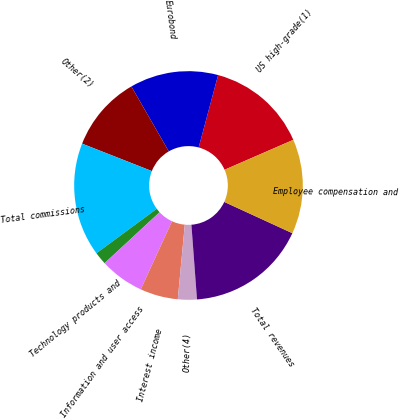Convert chart. <chart><loc_0><loc_0><loc_500><loc_500><pie_chart><fcel>US high-grade(1)<fcel>Eurobond<fcel>Other(2)<fcel>Total commissions<fcel>Technology products and<fcel>Information and user access<fcel>Interest income<fcel>Other(4)<fcel>Total revenues<fcel>Employee compensation and<nl><fcel>14.29%<fcel>12.5%<fcel>10.71%<fcel>16.07%<fcel>1.79%<fcel>6.25%<fcel>5.36%<fcel>2.68%<fcel>16.96%<fcel>13.39%<nl></chart> 